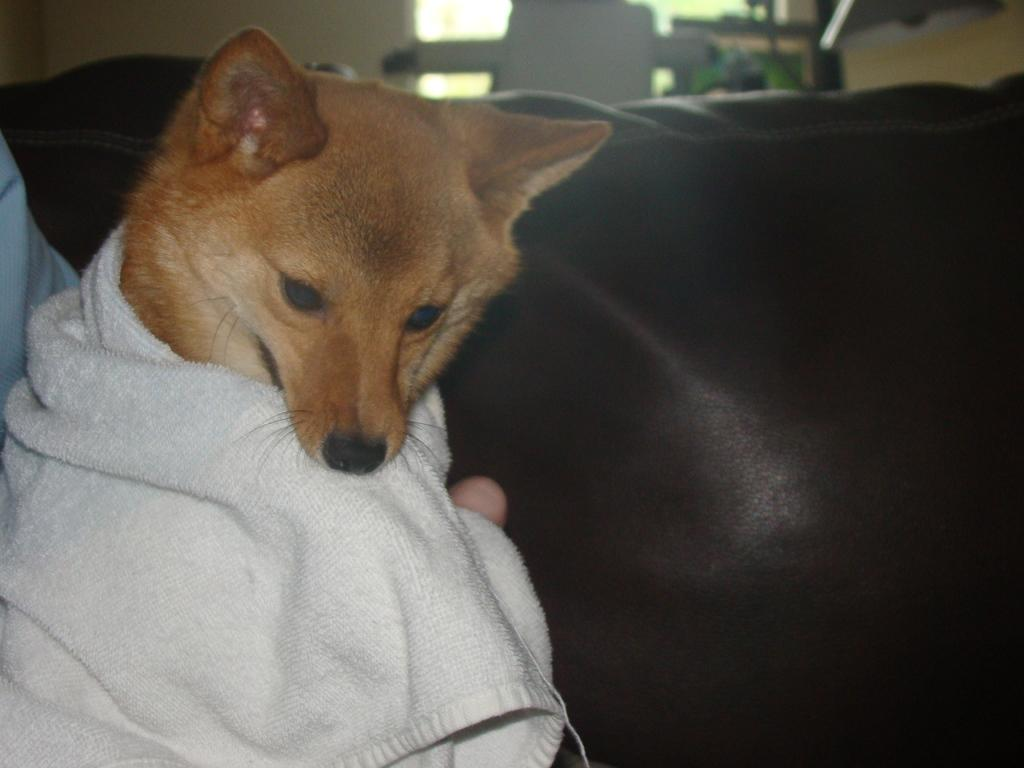What type of animal is present in the image? There is a dog in the image. What is the dog wearing? The dog is wearing a towel. What piece of furniture can be seen in the middle of the image? There is a sofa in the middle of the image. What type of stone is the dog sitting on in the image? There is no stone present in the image; the dog is wearing a towel and is likely on a floor or carpeted surface. What type of treatment is the dog receiving in the image? There is no indication in the image that the dog is receiving any treatment. 